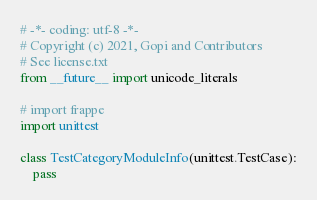Convert code to text. <code><loc_0><loc_0><loc_500><loc_500><_Python_># -*- coding: utf-8 -*-
# Copyright (c) 2021, Gopi and Contributors
# See license.txt
from __future__ import unicode_literals

# import frappe
import unittest

class TestCategoryModuleInfo(unittest.TestCase):
	pass
</code> 